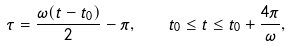<formula> <loc_0><loc_0><loc_500><loc_500>\tau = \frac { \omega ( t - t _ { 0 } ) } { 2 } - \pi , \quad t _ { 0 } \leq t \leq t _ { 0 } + \frac { 4 \pi } { \omega } ,</formula> 